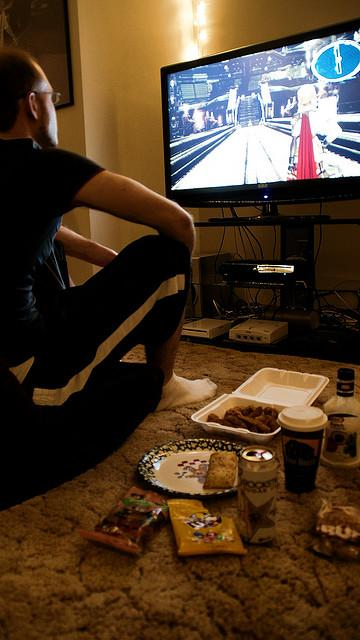What type dressing does this man favor? ranch 